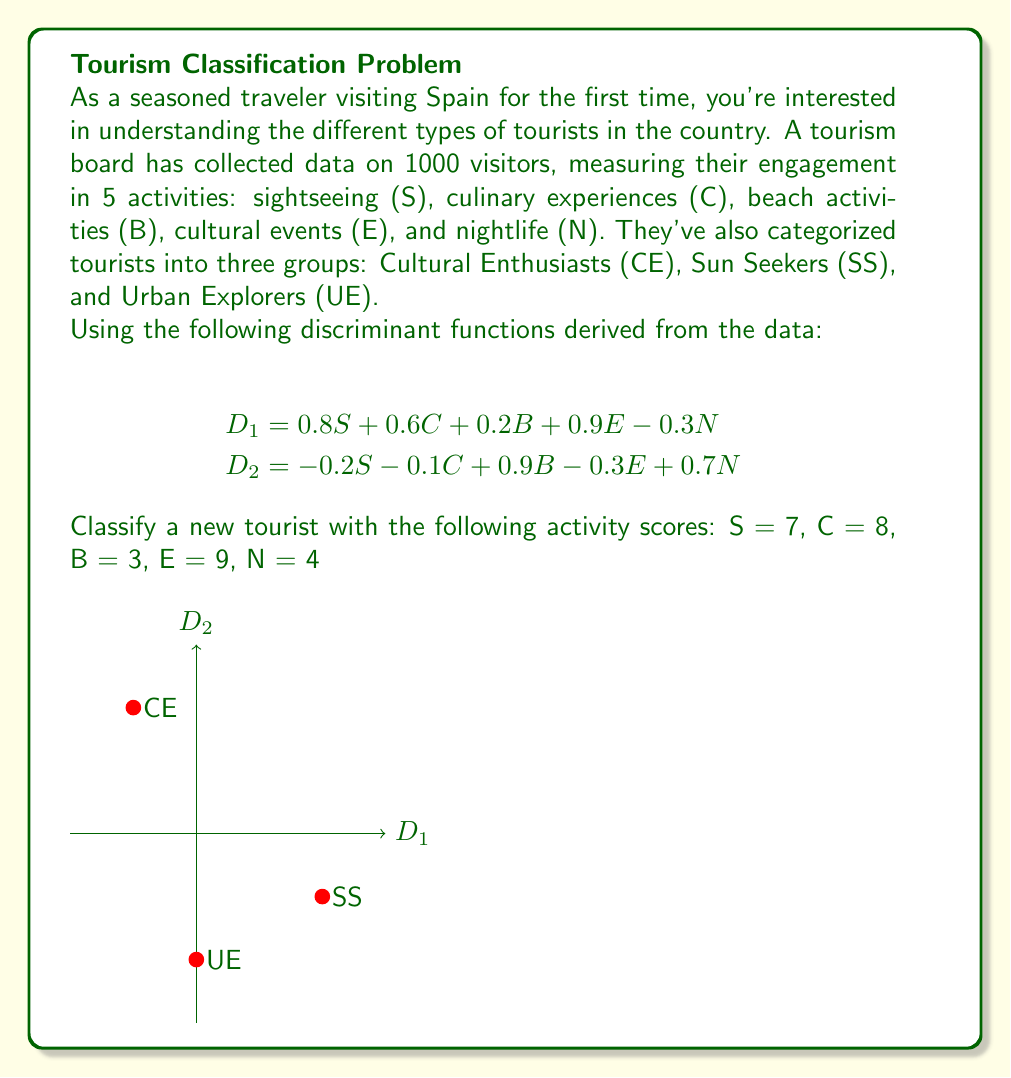Can you answer this question? To classify the new tourist, we need to follow these steps:

1) Calculate the discriminant scores D1 and D2 using the given functions and the tourist's activity scores.

For D1:
$$\begin{align}
D_1 &= 0.8S + 0.6C + 0.2B + 0.9E - 0.3N \\
&= 0.8(7) + 0.6(8) + 0.2(3) + 0.9(9) - 0.3(4) \\
&= 5.6 + 4.8 + 0.6 + 8.1 - 1.2 \\
&= 17.9
\end{align}$$

For D2:
$$\begin{align}
D_2 &= -0.2S - 0.1C + 0.9B - 0.3E + 0.7N \\
&= -0.2(7) - 0.1(8) + 0.9(3) - 0.3(9) + 0.7(4) \\
&= -1.4 - 0.8 + 2.7 - 2.7 + 2.8 \\
&= 0.6
\end{align}$$

2) Plot the point (17.9, 0.6) on the discriminant space shown in the diagram.

3) Determine which group centroid (CE, SS, or UE) is closest to this point. From the diagram, we can see that the point (17.9, 0.6) is closest to the CE (Cultural Enthusiast) centroid.

4) Classify the tourist based on the nearest centroid.
Answer: Cultural Enthusiast (CE) 